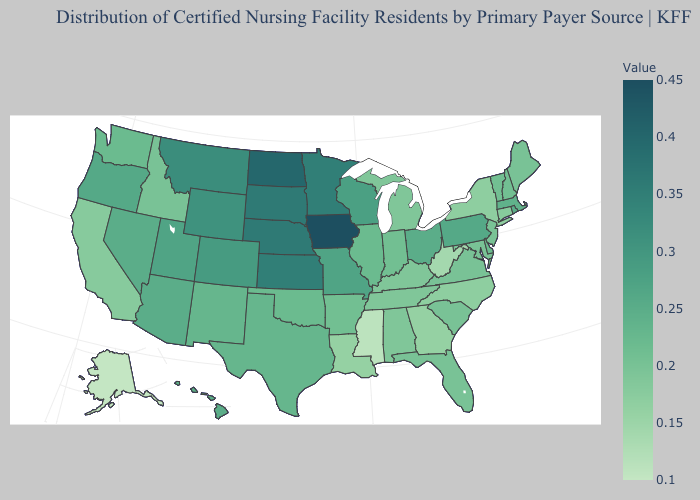Does Rhode Island have a lower value than New Jersey?
Write a very short answer. No. Among the states that border Massachusetts , does New York have the lowest value?
Quick response, please. Yes. Does New Jersey have the highest value in the Northeast?
Write a very short answer. No. Which states have the lowest value in the West?
Short answer required. Alaska. 